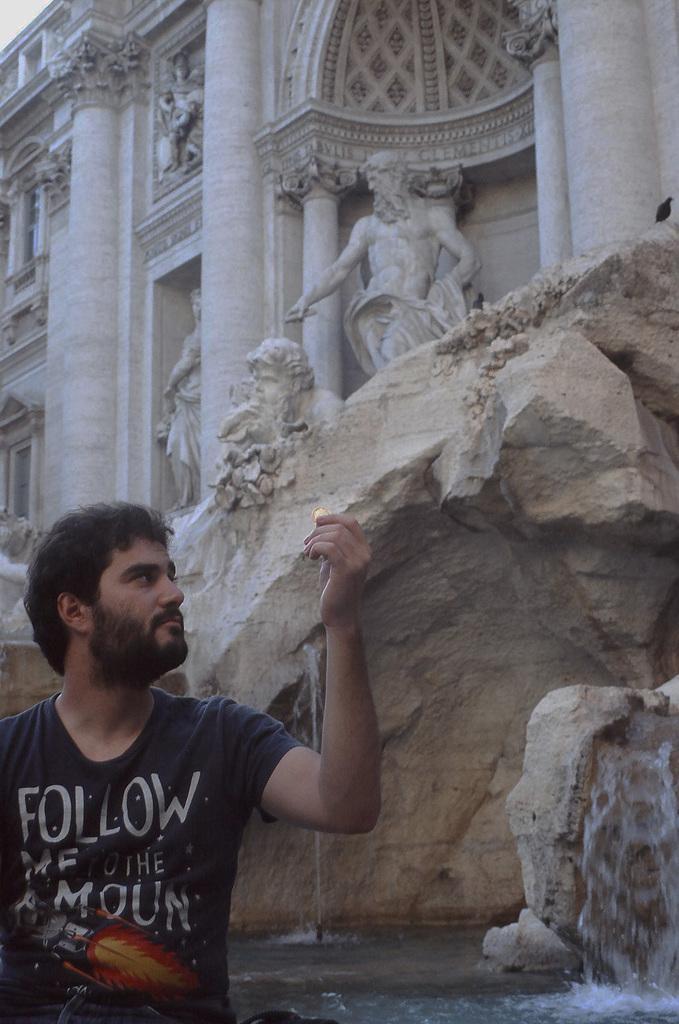How would you summarize this image in a sentence or two? In this image we can see a person wearing black color T-shirt sitting and in the background of the image there is water and some statues of human beings which are attached to the wall of a building. 